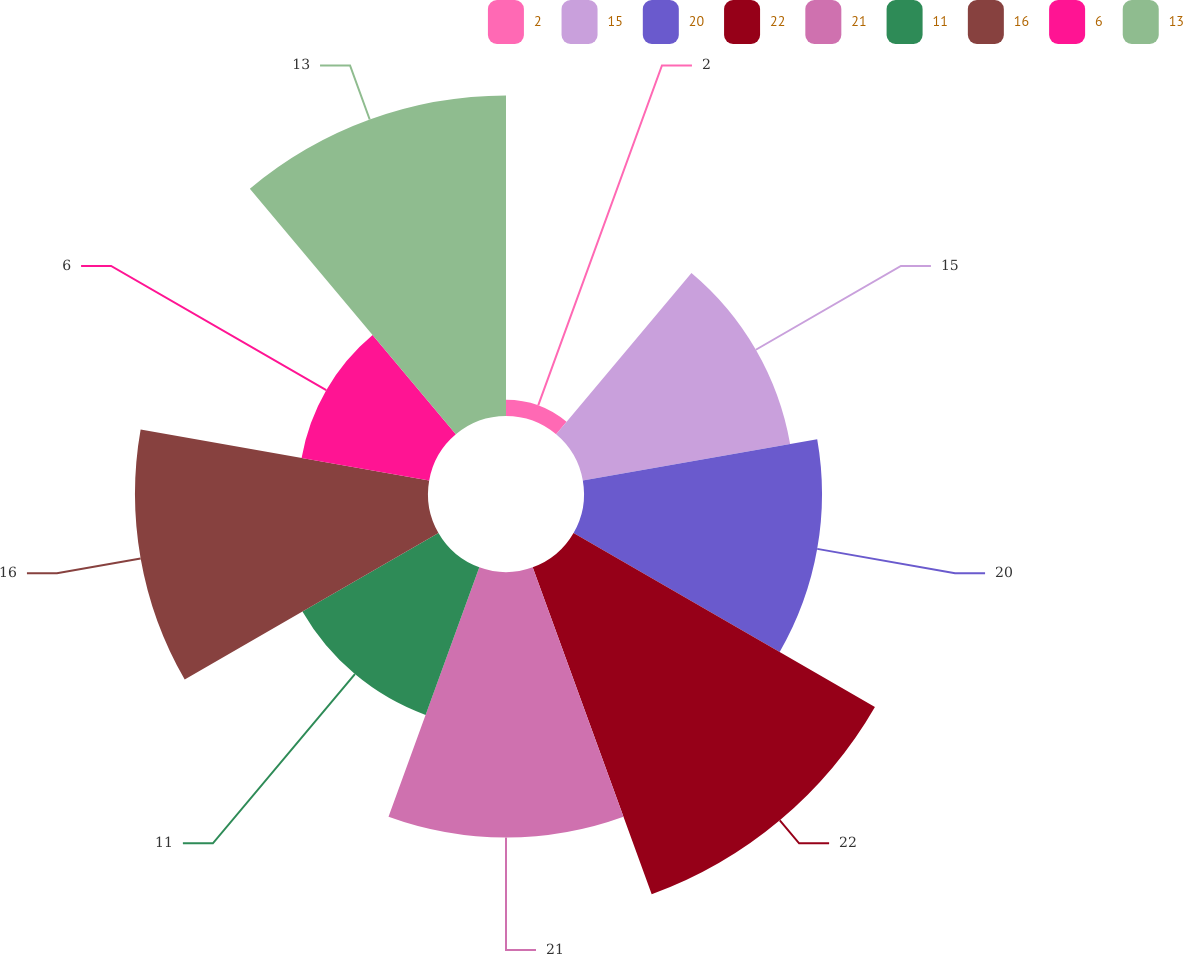Convert chart to OTSL. <chart><loc_0><loc_0><loc_500><loc_500><pie_chart><fcel>2<fcel>15<fcel>20<fcel>22<fcel>21<fcel>11<fcel>16<fcel>6<fcel>13<nl><fcel>0.82%<fcel>10.64%<fcel>12.03%<fcel>17.59%<fcel>13.42%<fcel>7.94%<fcel>14.81%<fcel>6.55%<fcel>16.2%<nl></chart> 